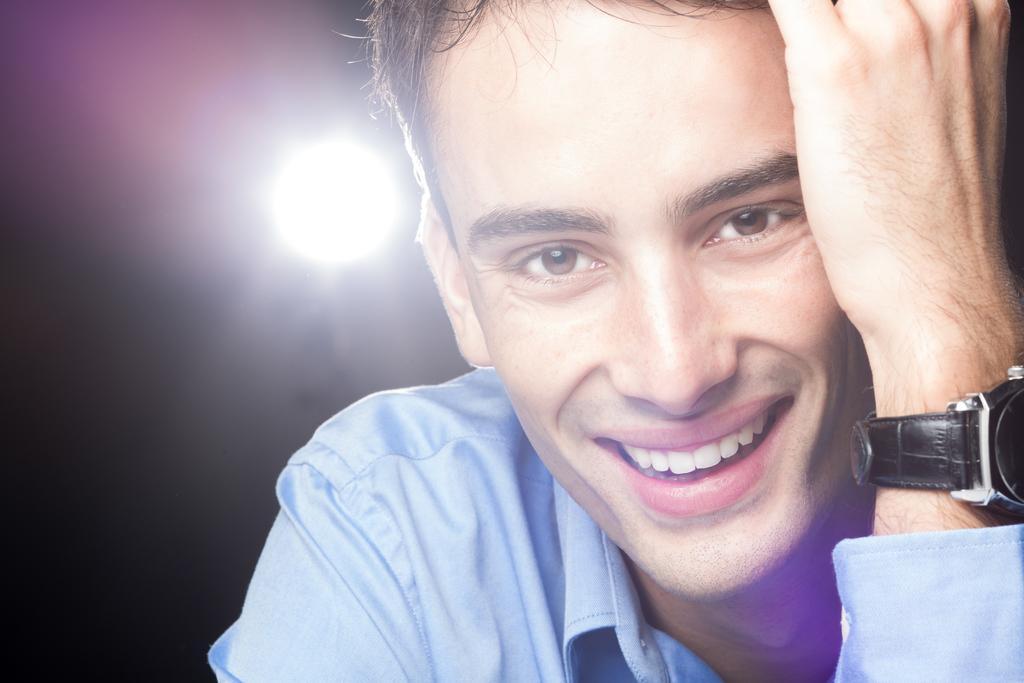Please provide a concise description of this image. In this image we can see a person smiling. On the person's hand, we can see a watch. Behind the person we can see a light. 